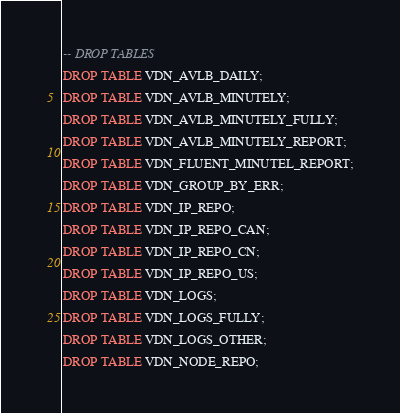Convert code to text. <code><loc_0><loc_0><loc_500><loc_500><_SQL_>-- DROP TABLES

DROP TABLE VDN_AVLB_DAILY;

DROP TABLE VDN_AVLB_MINUTELY;

DROP TABLE VDN_AVLB_MINUTELY_FULLY;

DROP TABLE VDN_AVLB_MINUTELY_REPORT;

DROP TABLE VDN_FLUENT_MINUTEL_REPORT;

DROP TABLE VDN_GROUP_BY_ERR;

DROP TABLE VDN_IP_REPO;

DROP TABLE VDN_IP_REPO_CAN;

DROP TABLE VDN_IP_REPO_CN;

DROP TABLE VDN_IP_REPO_US;

DROP TABLE VDN_LOGS;

DROP TABLE VDN_LOGS_FULLY;

DROP TABLE VDN_LOGS_OTHER;

DROP TABLE VDN_NODE_REPO;</code> 